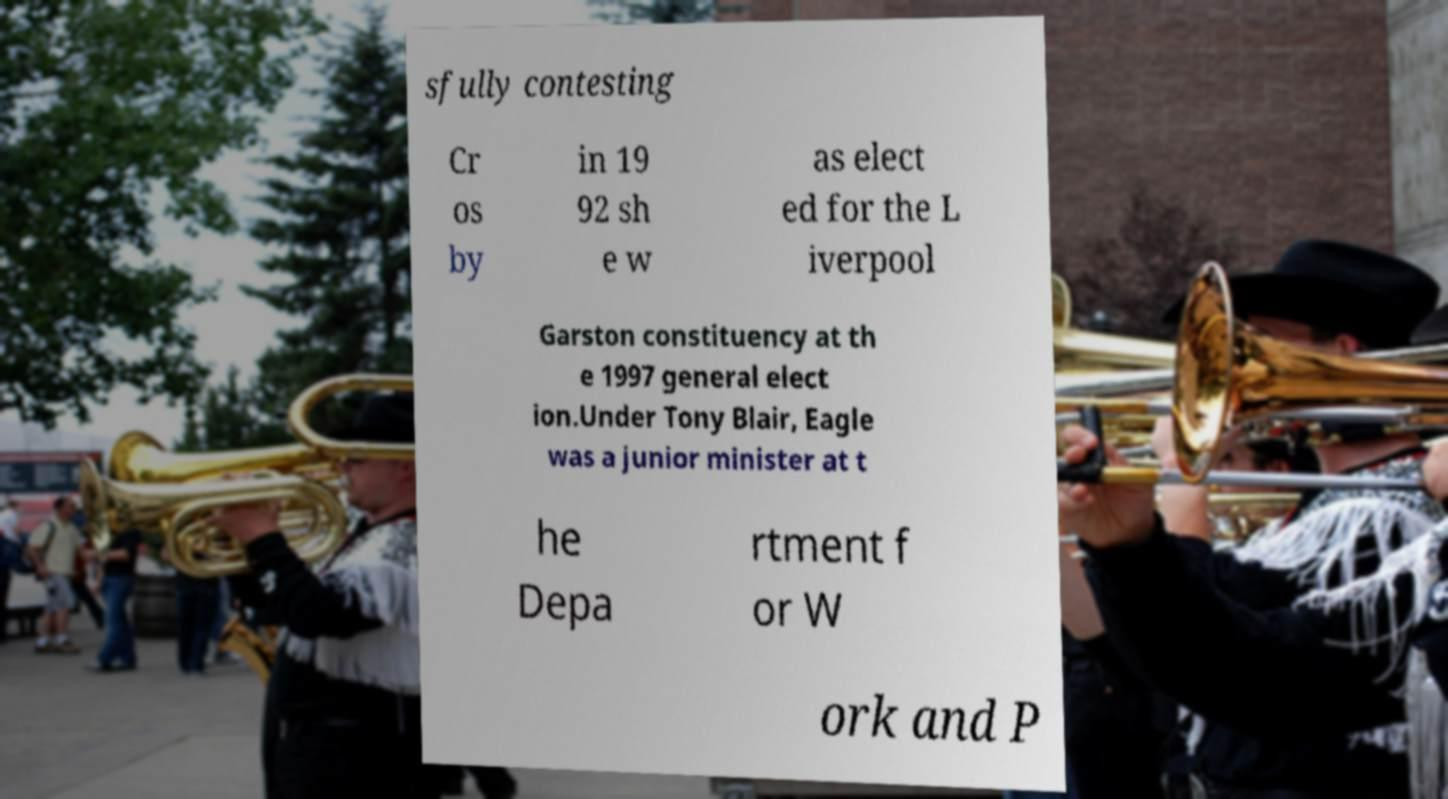Please identify and transcribe the text found in this image. sfully contesting Cr os by in 19 92 sh e w as elect ed for the L iverpool Garston constituency at th e 1997 general elect ion.Under Tony Blair, Eagle was a junior minister at t he Depa rtment f or W ork and P 